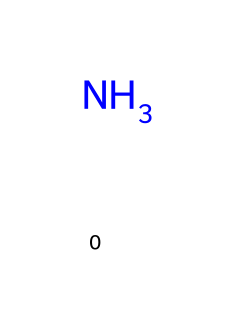What is the molecular formula of R-717? The SMILES representation indicates a single nitrogen atom attached to three hydrogen atoms, which composes the molecular formula NH3.
Answer: NH3 How many hydrogen atoms are present in this chemical? The SMILES shows three hydrogen atoms (H) bonded to the nitrogen atom (N), indicating a total of three hydrogen atoms.
Answer: 3 What type of compound is R-717? The presence of nitrogen and hydrogen in this structure categorizes R-717 as an amine, specifically an inorganic amine because it contains a simple nitrogen and hydrogen structure.
Answer: amine Is R-717 flammable? Ammonia is known to be flammable under certain conditions; however, it is generally classified as non-flammable at room temperature, but can burn in certain circumstances.
Answer: no What is the primary usage of R-717 in industrial applications? R-717 is widely used as a refrigerant in industrial refrigeration systems due to its efficient heat transfer capabilities and low environmental impact compared to other refrigerants.
Answer: refrigeration How does ammonia contribute to being an environmentally friendly refrigerant? Ammonia (R-717) has zero ozone depletion potential and a low global warming potential, making it more favorable for the environment than many synthetic refrigerants.
Answer: environmentally friendly What number of valence electrons does the nitrogen atom in R-717 have? Nitrogen typically has five valence electrons in its outer shell, which influences its bonding in the ammonia molecule.
Answer: 5 